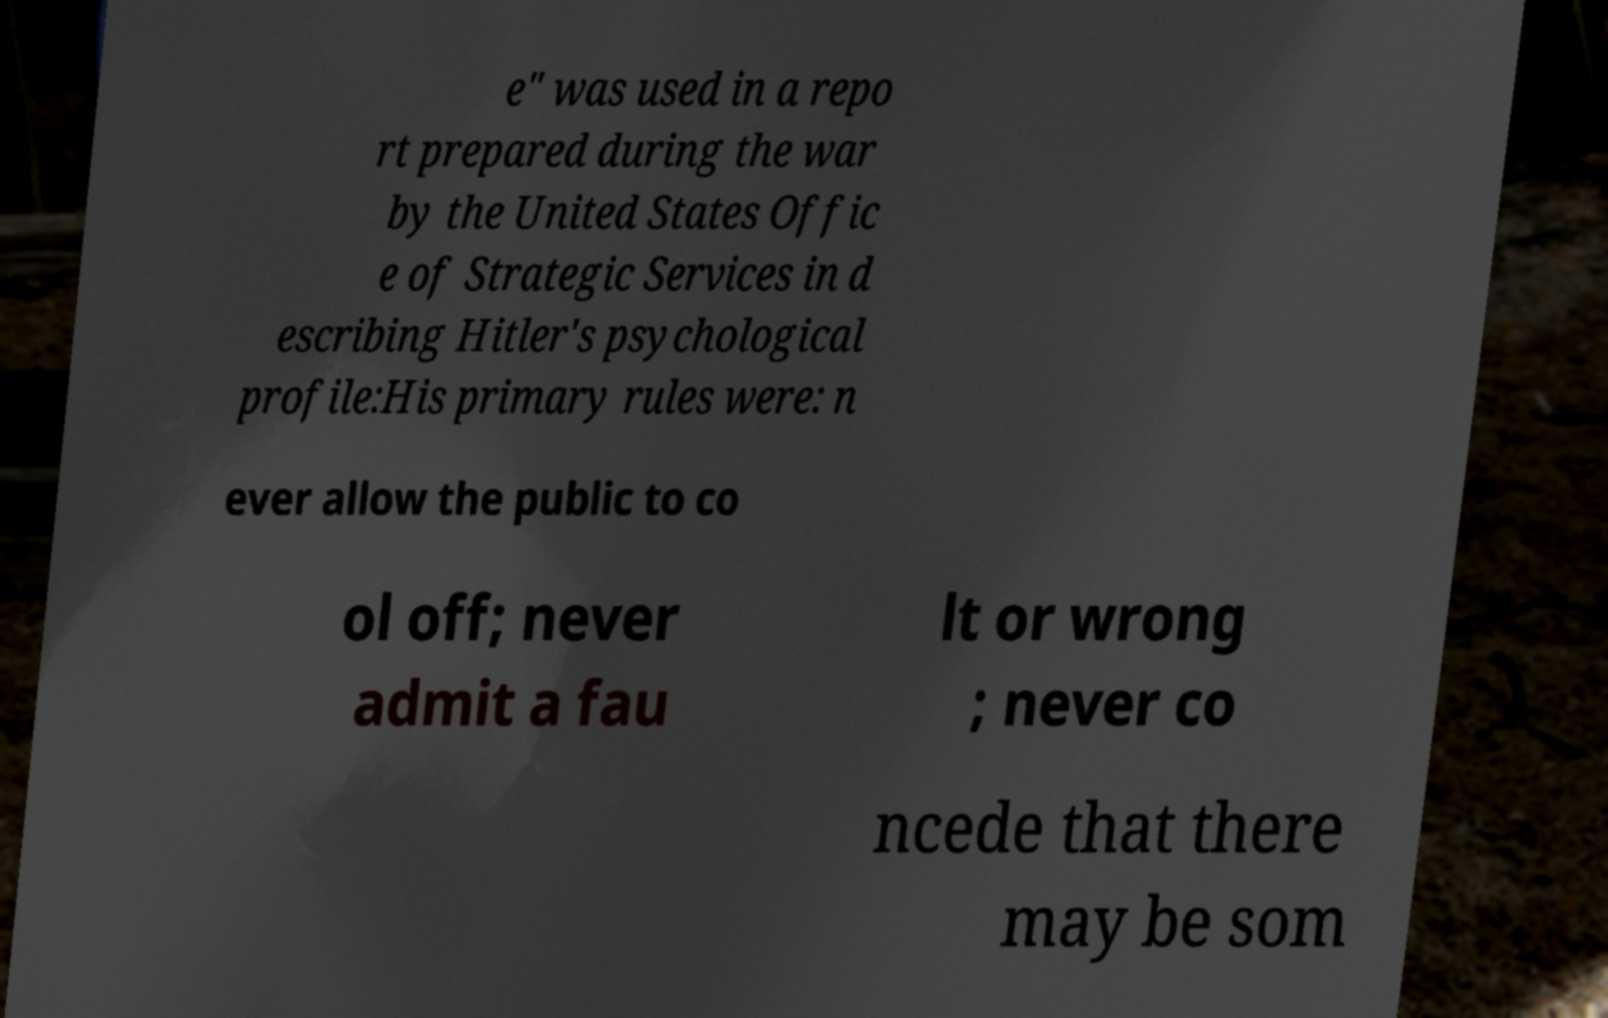Could you assist in decoding the text presented in this image and type it out clearly? e" was used in a repo rt prepared during the war by the United States Offic e of Strategic Services in d escribing Hitler's psychological profile:His primary rules were: n ever allow the public to co ol off; never admit a fau lt or wrong ; never co ncede that there may be som 